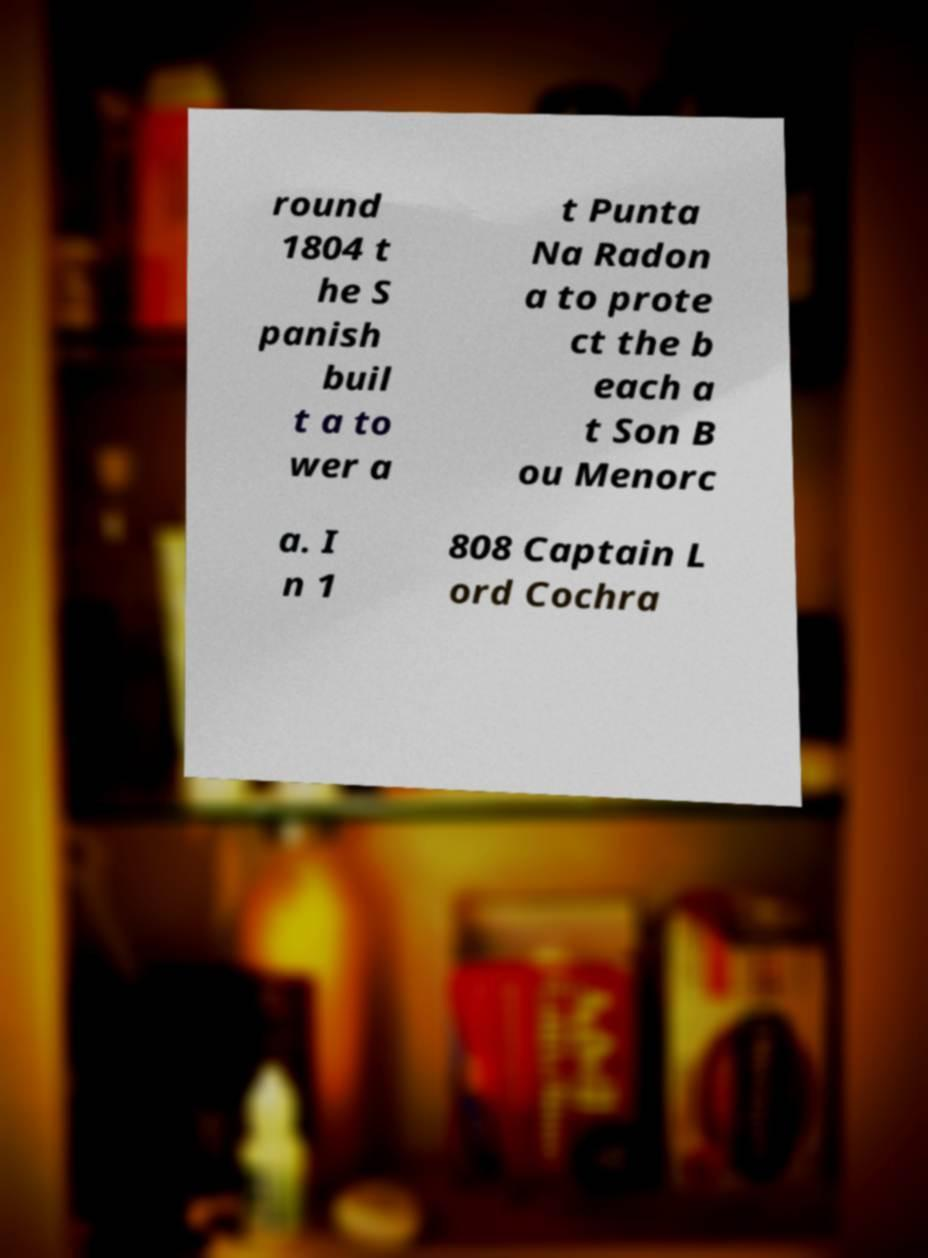There's text embedded in this image that I need extracted. Can you transcribe it verbatim? round 1804 t he S panish buil t a to wer a t Punta Na Radon a to prote ct the b each a t Son B ou Menorc a. I n 1 808 Captain L ord Cochra 